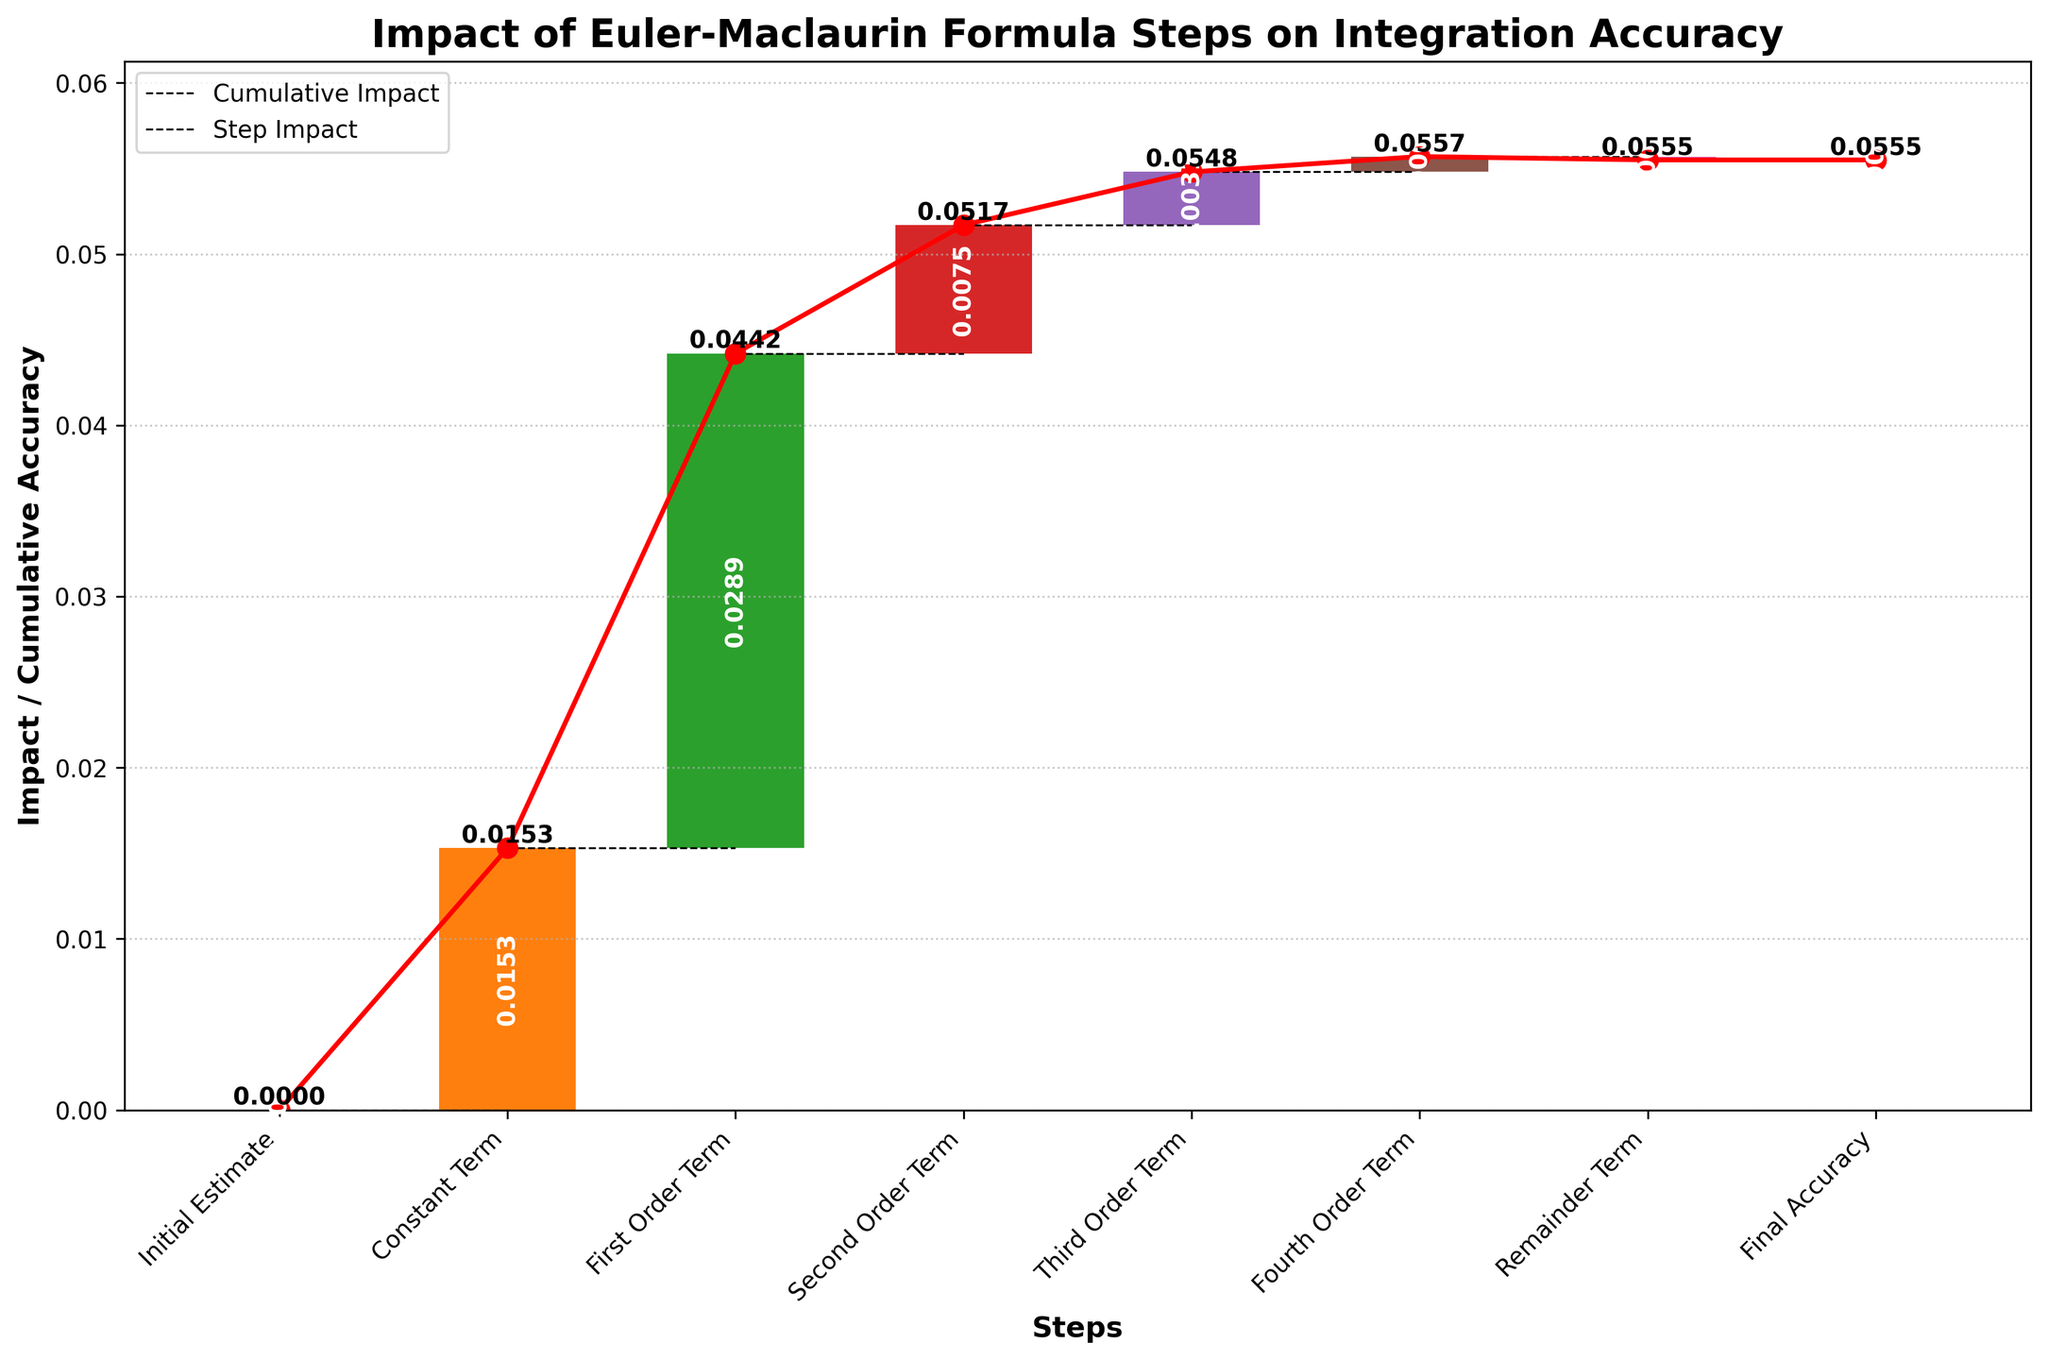What is the title of the chart? The title of the chart is displayed at the top and reads "Impact of Euler-Maclaurin Formula Steps on Integration Accuracy."
Answer: Impact of Euler-Maclaurin Formula Steps on Integration Accuracy What is the cumulative impact at the Second Order Term step? The cumulative impact at the Second Order Term step can be found by looking at the corresponding cumulative value at that step, which is labeled on the bar or the cumulative line.
Answer: 0.0517 Which step has the highest individual impact on integration accuracy? To determine the step with the highest individual impact, compare the heights of the bars representing each step. The highest bar represents the step with the highest impact.
Answer: First Order Term How many steps have a positive impact on the integration accuracy? Count the number of steps where the bars are above the zero line indicating positive impact.
Answer: 6 What is the impact of the Constant Term step? Find the height of the bar labeled Constant Term, which represents its impact.
Answer: 0.0153 What is the cumulative impact before the Final Accuracy step? Look at the cumulative value immediately before the Final Accuracy step, which is labeled on the cumulative line.
Answer: 0.0555 Which step has the smallest positive individual impact? Compare the heights of the bars that are above the zero line, and identify the smallest one.
Answer: Fourth Order Term By how much does the First Order Term increase the cumulative accuracy? The increase due to the First Order Term is the difference between its cumulative impact and the previous cumulative impact.
Answer: 0.0289 What is the difference in cumulative impact between the Constant Term and the Fourth Order Term? Subtract the cumulative impact at the Constant Term step from the cumulative impact at the Fourth Order Term step.
Answer: 0.0404 